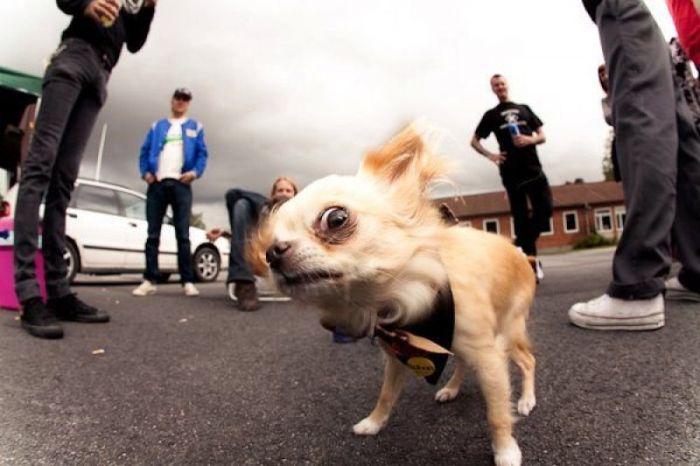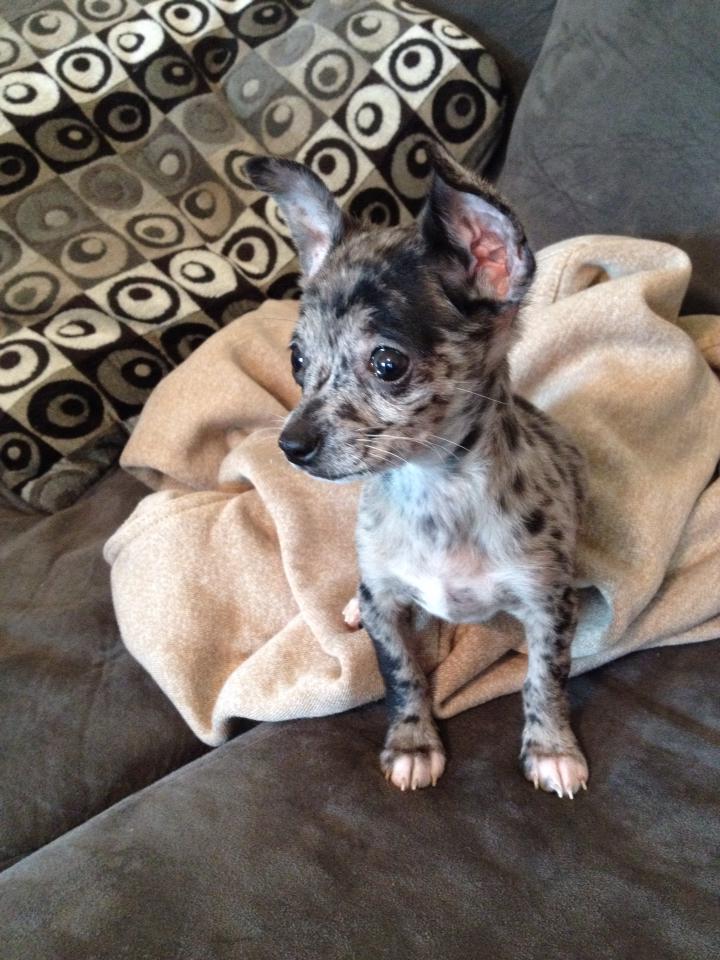The first image is the image on the left, the second image is the image on the right. Given the left and right images, does the statement "At least one of the images contains only one chihuahuas." hold true? Answer yes or no. Yes. 